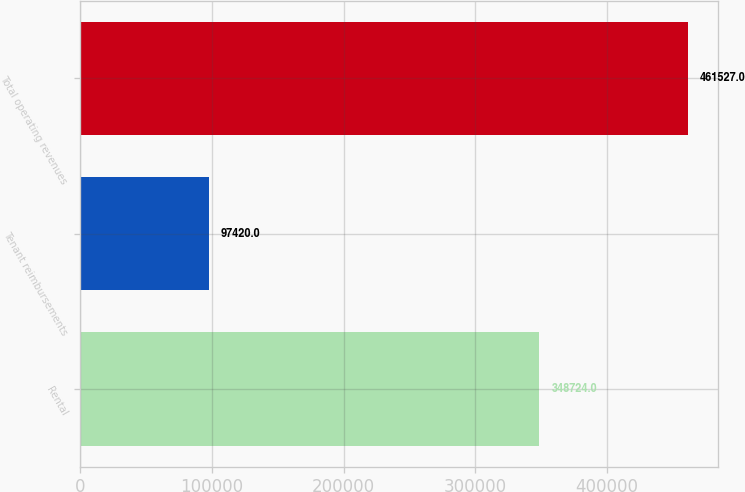Convert chart. <chart><loc_0><loc_0><loc_500><loc_500><bar_chart><fcel>Rental<fcel>Tenant reimbursements<fcel>Total operating revenues<nl><fcel>348724<fcel>97420<fcel>461527<nl></chart> 